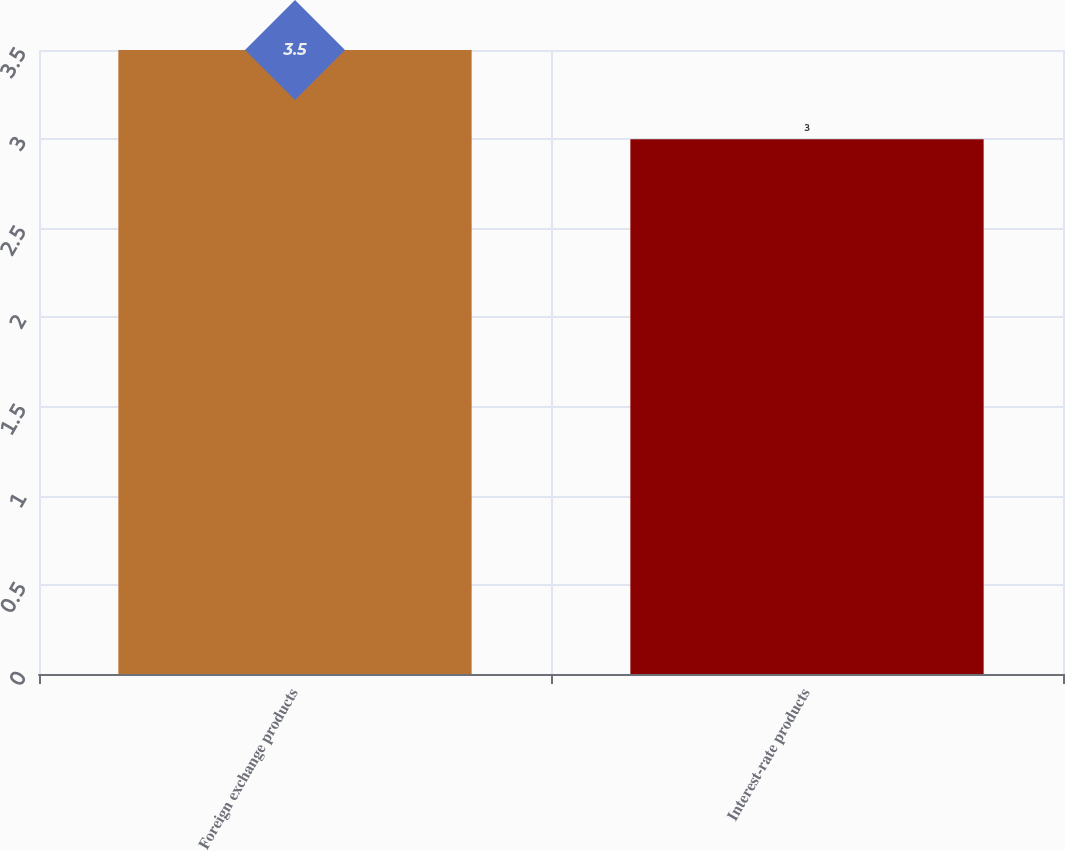<chart> <loc_0><loc_0><loc_500><loc_500><bar_chart><fcel>Foreign exchange products<fcel>Interest-rate products<nl><fcel>3.5<fcel>3<nl></chart> 